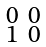<formula> <loc_0><loc_0><loc_500><loc_500>\begin{smallmatrix} 0 & 0 \\ 1 & 0 \\ \end{smallmatrix}</formula> 